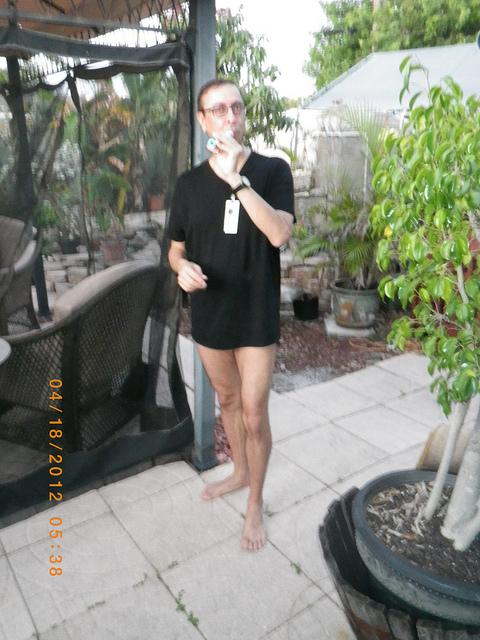Who is likely taking this picture in relation to the person who poses? Please explain your reasoning. intimate friend. The man who is posing is in a back yard and is partially naked. the person taking the picture must be someone he knows and trusts. 